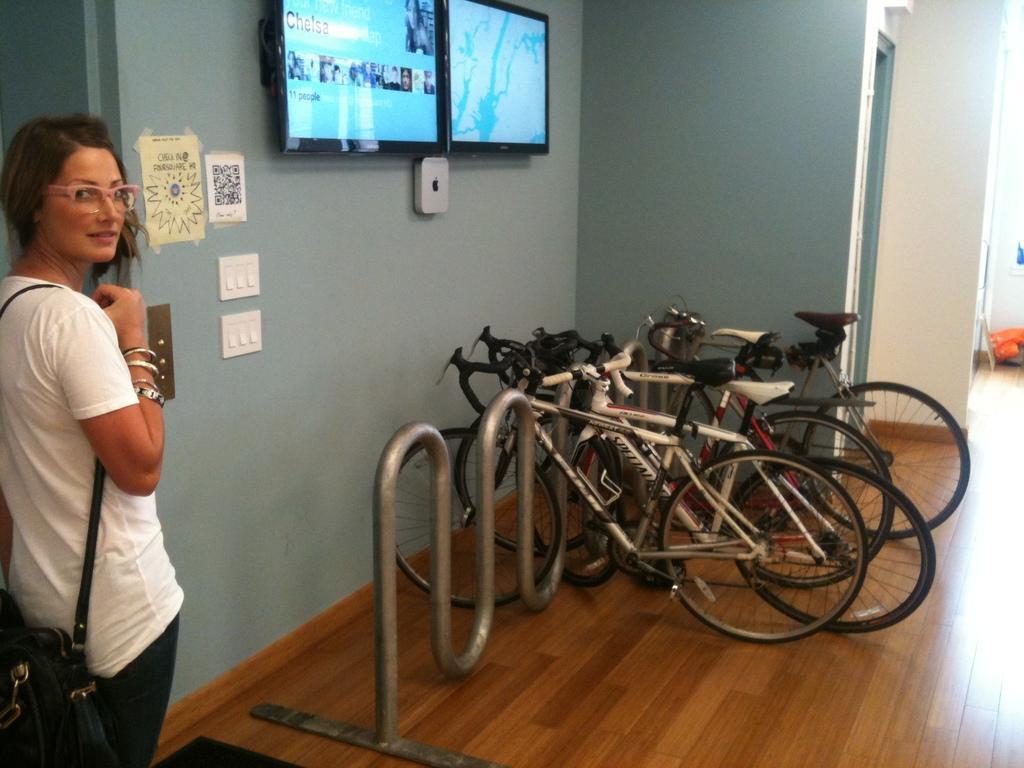Can you describe this image briefly? In this image we can see a woman standing on the floor. We can also see some bicycles placed in a metal stand, two television screens with a device, a switch board and some papers pasted on a wall. On the right side we can see a door and some objects on the floor. 